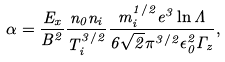Convert formula to latex. <formula><loc_0><loc_0><loc_500><loc_500>\alpha = \frac { E _ { x } } { B ^ { 2 } } \frac { n _ { 0 } n _ { i } } { T _ { i } ^ { 3 / 2 } } \frac { m _ { i } ^ { 1 / 2 } e ^ { 3 } \ln { \Lambda } } { 6 \sqrt { 2 } \pi ^ { 3 / 2 } \epsilon _ { 0 } ^ { 2 } \Gamma _ { z } } ,</formula> 